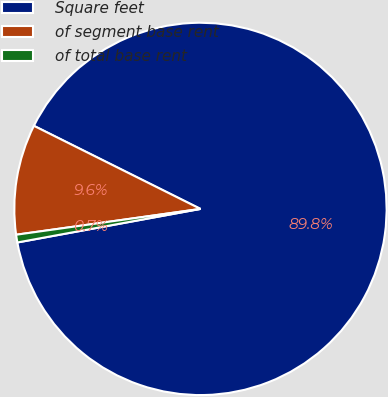Convert chart. <chart><loc_0><loc_0><loc_500><loc_500><pie_chart><fcel>Square feet<fcel>of segment base rent<fcel>of total base rent<nl><fcel>89.75%<fcel>9.58%<fcel>0.67%<nl></chart> 